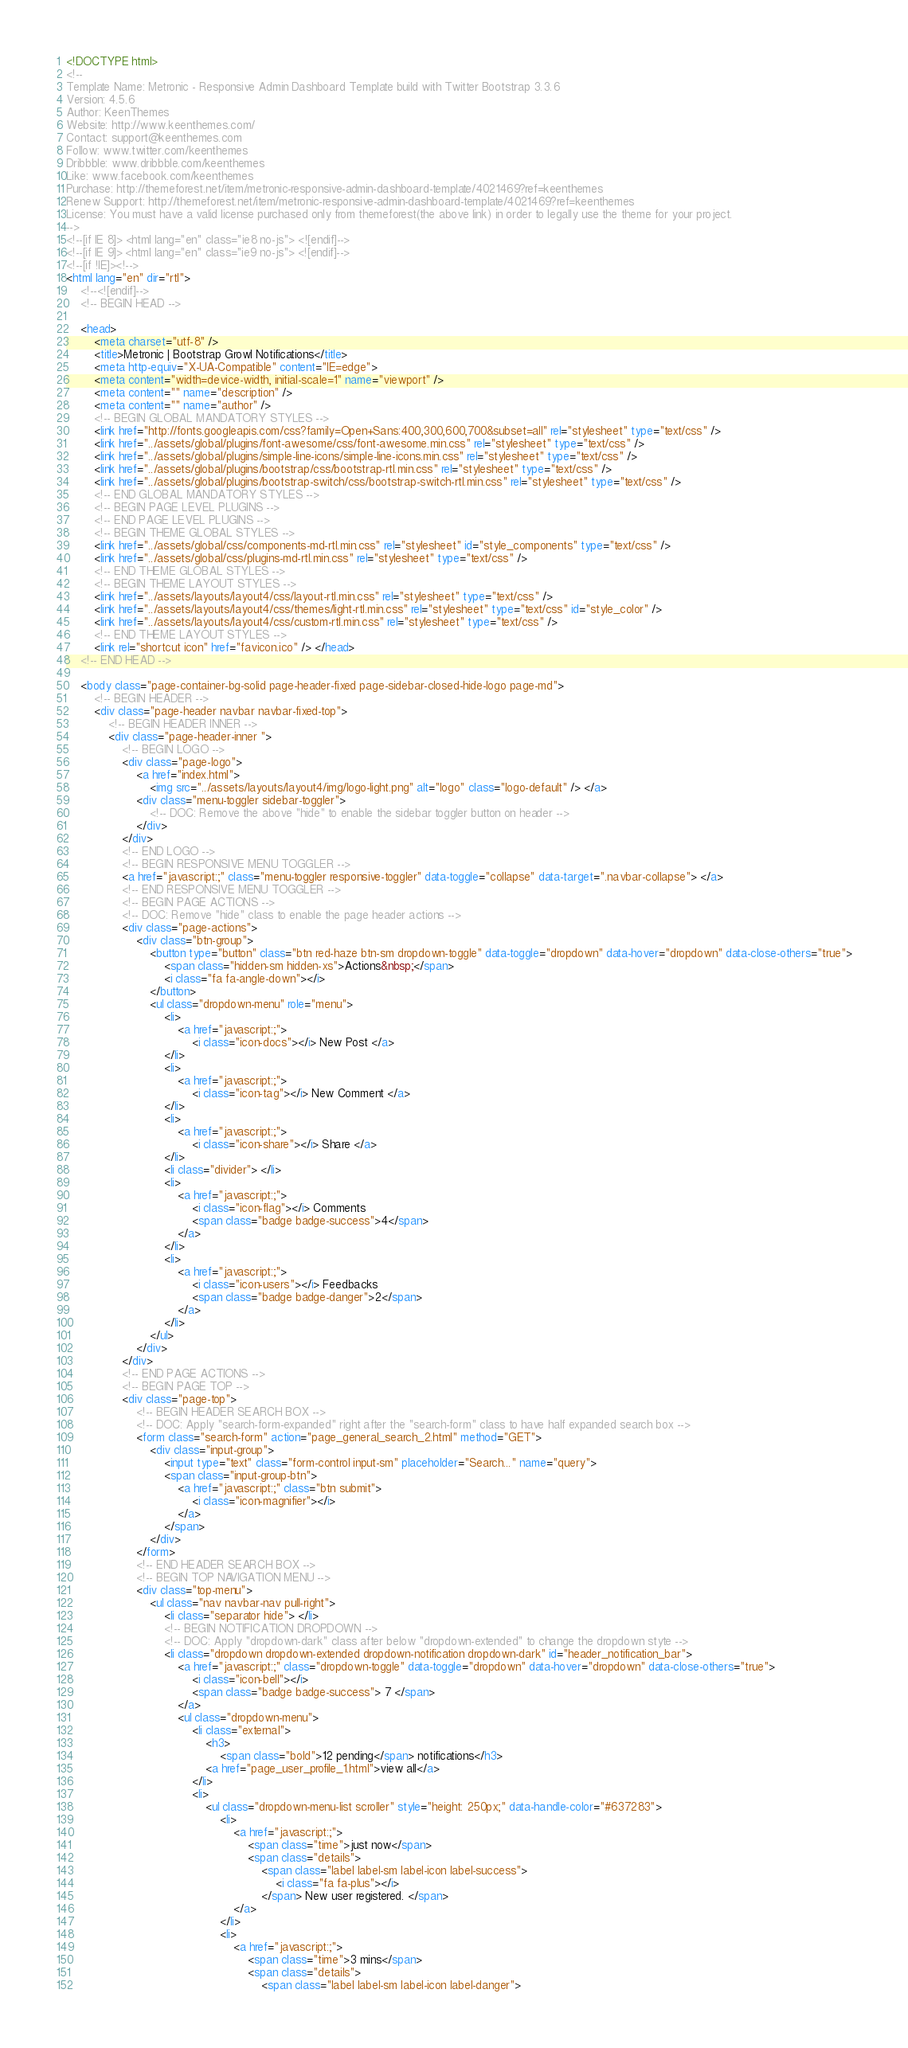Convert code to text. <code><loc_0><loc_0><loc_500><loc_500><_HTML_><!DOCTYPE html>
<!-- 
Template Name: Metronic - Responsive Admin Dashboard Template build with Twitter Bootstrap 3.3.6
Version: 4.5.6
Author: KeenThemes
Website: http://www.keenthemes.com/
Contact: support@keenthemes.com
Follow: www.twitter.com/keenthemes
Dribbble: www.dribbble.com/keenthemes
Like: www.facebook.com/keenthemes
Purchase: http://themeforest.net/item/metronic-responsive-admin-dashboard-template/4021469?ref=keenthemes
Renew Support: http://themeforest.net/item/metronic-responsive-admin-dashboard-template/4021469?ref=keenthemes
License: You must have a valid license purchased only from themeforest(the above link) in order to legally use the theme for your project.
-->
<!--[if IE 8]> <html lang="en" class="ie8 no-js"> <![endif]-->
<!--[if IE 9]> <html lang="en" class="ie9 no-js"> <![endif]-->
<!--[if !IE]><!-->
<html lang="en" dir="rtl">
    <!--<![endif]-->
    <!-- BEGIN HEAD -->

    <head>
        <meta charset="utf-8" />
        <title>Metronic | Bootstrap Growl Notifications</title>
        <meta http-equiv="X-UA-Compatible" content="IE=edge">
        <meta content="width=device-width, initial-scale=1" name="viewport" />
        <meta content="" name="description" />
        <meta content="" name="author" />
        <!-- BEGIN GLOBAL MANDATORY STYLES -->
        <link href="http://fonts.googleapis.com/css?family=Open+Sans:400,300,600,700&subset=all" rel="stylesheet" type="text/css" />
        <link href="../assets/global/plugins/font-awesome/css/font-awesome.min.css" rel="stylesheet" type="text/css" />
        <link href="../assets/global/plugins/simple-line-icons/simple-line-icons.min.css" rel="stylesheet" type="text/css" />
        <link href="../assets/global/plugins/bootstrap/css/bootstrap-rtl.min.css" rel="stylesheet" type="text/css" />
        <link href="../assets/global/plugins/bootstrap-switch/css/bootstrap-switch-rtl.min.css" rel="stylesheet" type="text/css" />
        <!-- END GLOBAL MANDATORY STYLES -->
        <!-- BEGIN PAGE LEVEL PLUGINS -->
        <!-- END PAGE LEVEL PLUGINS -->
        <!-- BEGIN THEME GLOBAL STYLES -->
        <link href="../assets/global/css/components-md-rtl.min.css" rel="stylesheet" id="style_components" type="text/css" />
        <link href="../assets/global/css/plugins-md-rtl.min.css" rel="stylesheet" type="text/css" />
        <!-- END THEME GLOBAL STYLES -->
        <!-- BEGIN THEME LAYOUT STYLES -->
        <link href="../assets/layouts/layout4/css/layout-rtl.min.css" rel="stylesheet" type="text/css" />
        <link href="../assets/layouts/layout4/css/themes/light-rtl.min.css" rel="stylesheet" type="text/css" id="style_color" />
        <link href="../assets/layouts/layout4/css/custom-rtl.min.css" rel="stylesheet" type="text/css" />
        <!-- END THEME LAYOUT STYLES -->
        <link rel="shortcut icon" href="favicon.ico" /> </head>
    <!-- END HEAD -->

    <body class="page-container-bg-solid page-header-fixed page-sidebar-closed-hide-logo page-md">
        <!-- BEGIN HEADER -->
        <div class="page-header navbar navbar-fixed-top">
            <!-- BEGIN HEADER INNER -->
            <div class="page-header-inner ">
                <!-- BEGIN LOGO -->
                <div class="page-logo">
                    <a href="index.html">
                        <img src="../assets/layouts/layout4/img/logo-light.png" alt="logo" class="logo-default" /> </a>
                    <div class="menu-toggler sidebar-toggler">
                        <!-- DOC: Remove the above "hide" to enable the sidebar toggler button on header -->
                    </div>
                </div>
                <!-- END LOGO -->
                <!-- BEGIN RESPONSIVE MENU TOGGLER -->
                <a href="javascript:;" class="menu-toggler responsive-toggler" data-toggle="collapse" data-target=".navbar-collapse"> </a>
                <!-- END RESPONSIVE MENU TOGGLER -->
                <!-- BEGIN PAGE ACTIONS -->
                <!-- DOC: Remove "hide" class to enable the page header actions -->
                <div class="page-actions">
                    <div class="btn-group">
                        <button type="button" class="btn red-haze btn-sm dropdown-toggle" data-toggle="dropdown" data-hover="dropdown" data-close-others="true">
                            <span class="hidden-sm hidden-xs">Actions&nbsp;</span>
                            <i class="fa fa-angle-down"></i>
                        </button>
                        <ul class="dropdown-menu" role="menu">
                            <li>
                                <a href="javascript:;">
                                    <i class="icon-docs"></i> New Post </a>
                            </li>
                            <li>
                                <a href="javascript:;">
                                    <i class="icon-tag"></i> New Comment </a>
                            </li>
                            <li>
                                <a href="javascript:;">
                                    <i class="icon-share"></i> Share </a>
                            </li>
                            <li class="divider"> </li>
                            <li>
                                <a href="javascript:;">
                                    <i class="icon-flag"></i> Comments
                                    <span class="badge badge-success">4</span>
                                </a>
                            </li>
                            <li>
                                <a href="javascript:;">
                                    <i class="icon-users"></i> Feedbacks
                                    <span class="badge badge-danger">2</span>
                                </a>
                            </li>
                        </ul>
                    </div>
                </div>
                <!-- END PAGE ACTIONS -->
                <!-- BEGIN PAGE TOP -->
                <div class="page-top">
                    <!-- BEGIN HEADER SEARCH BOX -->
                    <!-- DOC: Apply "search-form-expanded" right after the "search-form" class to have half expanded search box -->
                    <form class="search-form" action="page_general_search_2.html" method="GET">
                        <div class="input-group">
                            <input type="text" class="form-control input-sm" placeholder="Search..." name="query">
                            <span class="input-group-btn">
                                <a href="javascript:;" class="btn submit">
                                    <i class="icon-magnifier"></i>
                                </a>
                            </span>
                        </div>
                    </form>
                    <!-- END HEADER SEARCH BOX -->
                    <!-- BEGIN TOP NAVIGATION MENU -->
                    <div class="top-menu">
                        <ul class="nav navbar-nav pull-right">
                            <li class="separator hide"> </li>
                            <!-- BEGIN NOTIFICATION DROPDOWN -->
                            <!-- DOC: Apply "dropdown-dark" class after below "dropdown-extended" to change the dropdown styte -->
                            <li class="dropdown dropdown-extended dropdown-notification dropdown-dark" id="header_notification_bar">
                                <a href="javascript:;" class="dropdown-toggle" data-toggle="dropdown" data-hover="dropdown" data-close-others="true">
                                    <i class="icon-bell"></i>
                                    <span class="badge badge-success"> 7 </span>
                                </a>
                                <ul class="dropdown-menu">
                                    <li class="external">
                                        <h3>
                                            <span class="bold">12 pending</span> notifications</h3>
                                        <a href="page_user_profile_1.html">view all</a>
                                    </li>
                                    <li>
                                        <ul class="dropdown-menu-list scroller" style="height: 250px;" data-handle-color="#637283">
                                            <li>
                                                <a href="javascript:;">
                                                    <span class="time">just now</span>
                                                    <span class="details">
                                                        <span class="label label-sm label-icon label-success">
                                                            <i class="fa fa-plus"></i>
                                                        </span> New user registered. </span>
                                                </a>
                                            </li>
                                            <li>
                                                <a href="javascript:;">
                                                    <span class="time">3 mins</span>
                                                    <span class="details">
                                                        <span class="label label-sm label-icon label-danger"></code> 